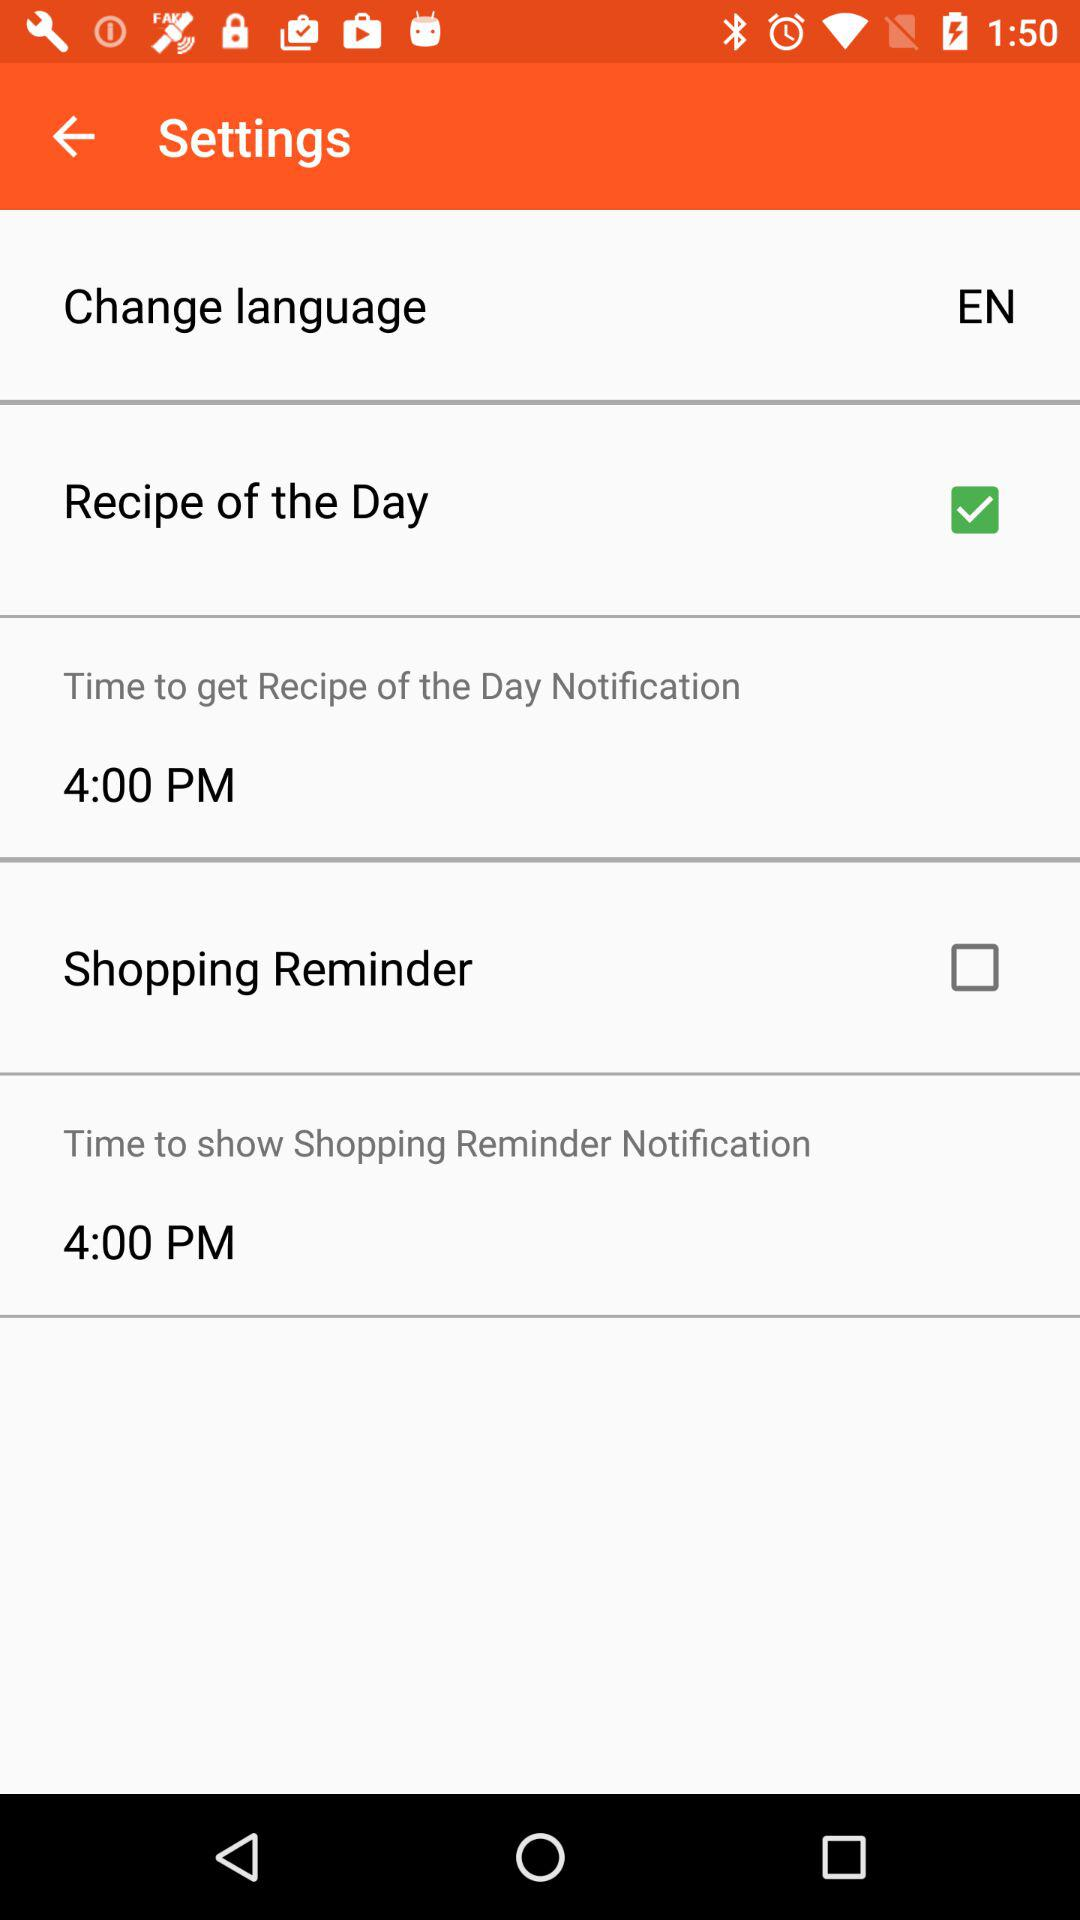Which language was selected? The selected language was English. 